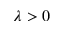<formula> <loc_0><loc_0><loc_500><loc_500>\lambda > 0</formula> 